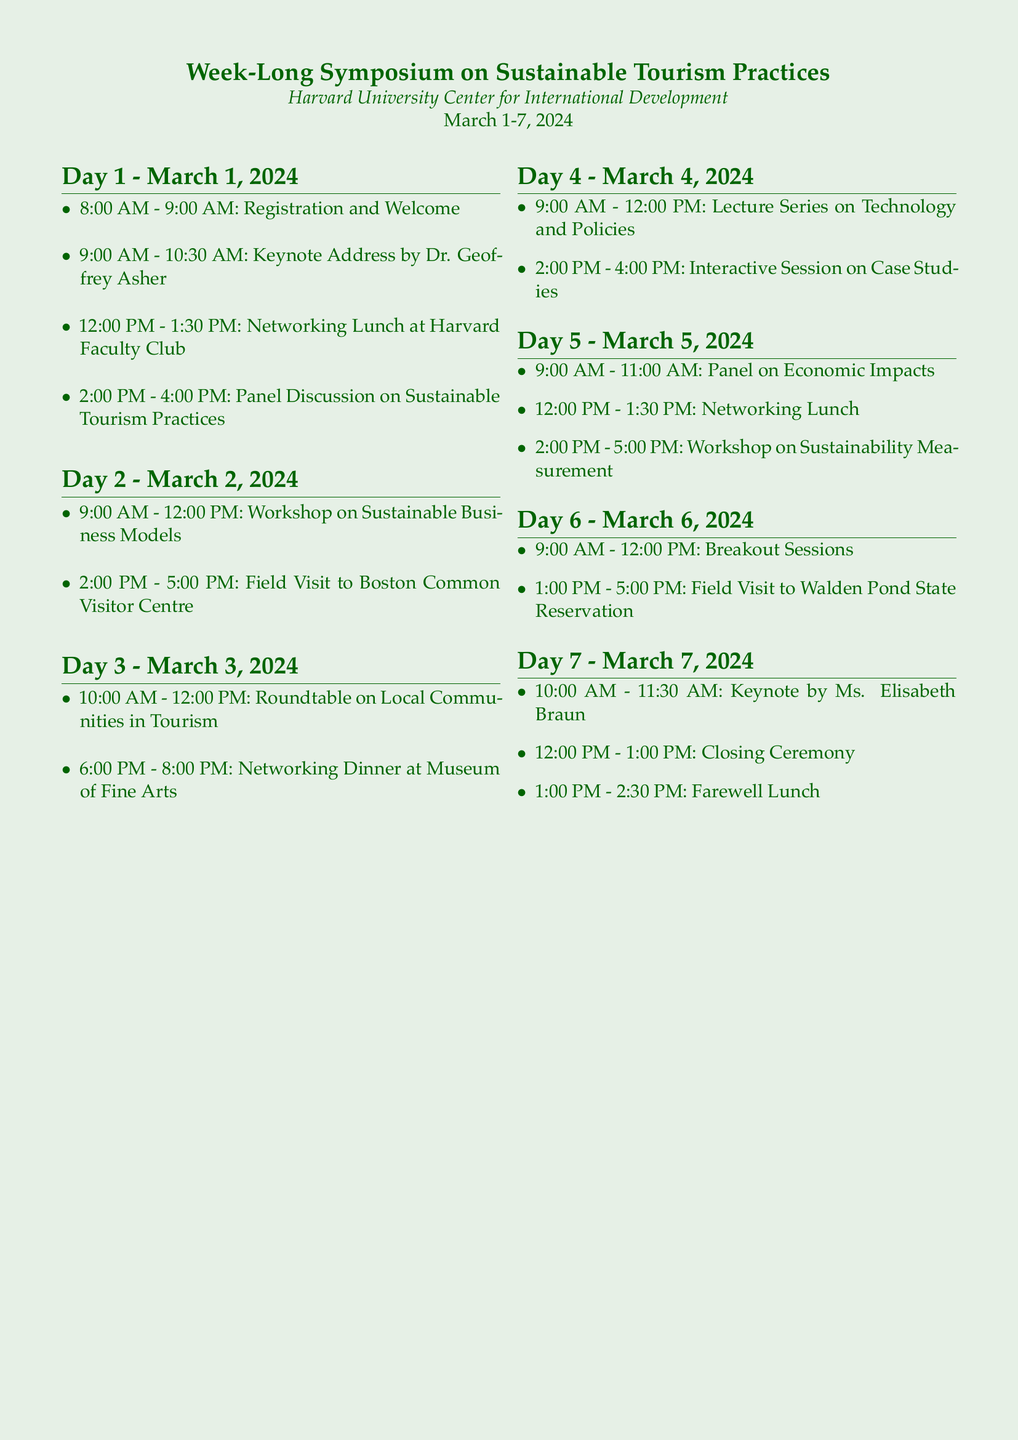What is the name of the keynote speaker on Day 1? The keynote speaker on Day 1 is named in the document as Dr. Geoffrey Asher.
Answer: Dr. Geoffrey Asher What time does the networking dinner take place on Day 3? The document states that the networking dinner is scheduled from 6:00 PM to 8:00 PM on Day 3.
Answer: 6:00 PM - 8:00 PM How many days is the symposium scheduled for? The document mentions that the symposium spans from March 1 to March 7, 2024, indicating a total of 7 days.
Answer: 7 days What is the focus of the workshop on Day 5? The workshop on Day 5 is focused on "Sustainability Measurement" as specified in the document.
Answer: Sustainability Measurement What event is scheduled right before the farewell lunch on Day 7? The document illustrates that the closing ceremony occurs just before the farewell lunch on Day 7.
Answer: Closing Ceremony What venue hosts the networking lunch on Day 1? According to the document, the networking lunch on Day 1 is held at the Harvard Faculty Club.
Answer: Harvard Faculty Club How long is the field visit on Day 6? The document indicates that the field visit on Day 6 is scheduled from 1:00 PM to 5:00 PM, lasting 4 hours.
Answer: 4 hours Which day features a roundtable discussion? The roundtable discussion takes place on Day 3, as stated in the document.
Answer: Day 3 What session type occurs in the morning on Day 4? The document specifies that a "Lecture Series" is scheduled for the morning on Day 4.
Answer: Lecture Series 